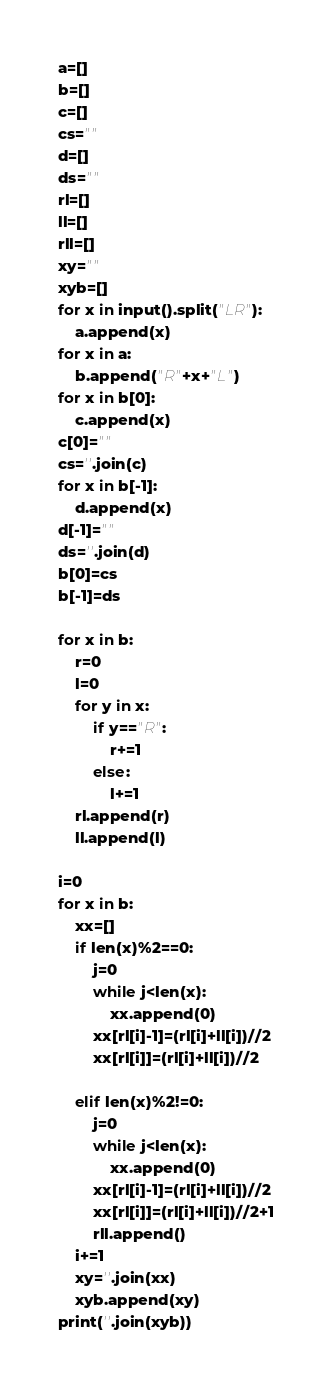<code> <loc_0><loc_0><loc_500><loc_500><_Python_>a=[]
b=[]
c=[]
cs=""
d=[]
ds=""
rl=[]
ll=[]
rll=[]
xy=""
xyb=[]
for x in input().split("LR"):
    a.append(x)
for x in a:
    b.append("R"+x+"L")
for x in b[0]:
    c.append(x)
c[0]=""
cs=''.join(c)
for x in b[-1]:
    d.append(x)
d[-1]=""
ds=''.join(d)
b[0]=cs
b[-1]=ds

for x in b:
    r=0
    l=0
    for y in x:
        if y=="R":
            r+=1
        else:
            l+=1
    rl.append(r)
    ll.append(l)

i=0
for x in b:
    xx=[]
    if len(x)%2==0:
        j=0
        while j<len(x):
            xx.append(0)
        xx[rl[i]-1]=(rl[i]+ll[i])//2
        xx[rl[i]]=(rl[i]+ll[i])//2
        
    elif len(x)%2!=0:
        j=0
        while j<len(x):
            xx.append(0)
        xx[rl[i]-1]=(rl[i]+ll[i])//2
        xx[rl[i]]=(rl[i]+ll[i])//2+1
        rll.append()
    i+=1
    xy=''.join(xx)
    xyb.append(xy)
print(''.join(xyb))</code> 